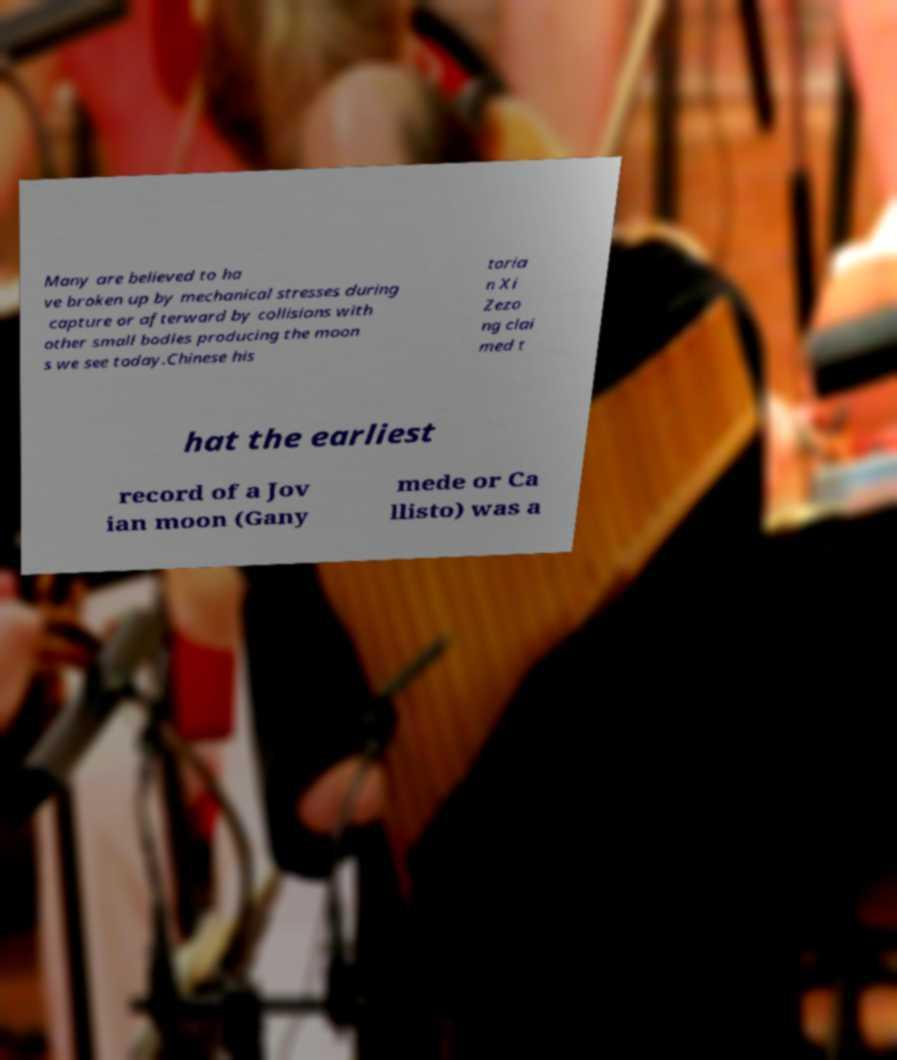Could you assist in decoding the text presented in this image and type it out clearly? Many are believed to ha ve broken up by mechanical stresses during capture or afterward by collisions with other small bodies producing the moon s we see today.Chinese his toria n Xi Zezo ng clai med t hat the earliest record of a Jov ian moon (Gany mede or Ca llisto) was a 